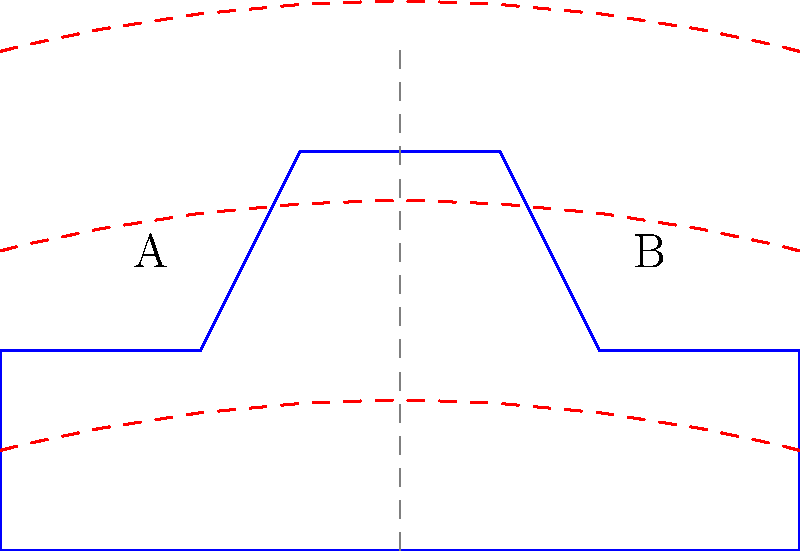In the diagram above, which area of the car design, A or B, is likely to create more drag during high-speed racing, and why? To analyze the aerodynamics of this car design, we need to consider the following steps:

1. Observe the airflow lines: The red dashed lines represent the airflow over the car.

2. Analyze the car's shape: 
   - Area A has a more abrupt transition from the hood to the windshield.
   - Area B has a smoother, more gradual slope from the roof to the rear.

3. Consider the principle of aerodynamic drag:
   - Drag increases when airflow separates from the car's surface.
   - Smooth, gradual curves allow air to flow more easily over the surface.

4. Compare the two areas:
   - Area A: The sharp angle between the hood and windshield is likely to cause air separation, creating turbulence and increasing drag.
   - Area B: The smoother curve allows air to flow more seamlessly over the surface, reducing drag.

5. Conclusion: Area A will likely create more drag during high-speed racing due to its sharper angle and potential for air separation.

This design principle is why modern race cars often have smoother, more streamlined shapes to minimize drag and improve performance at high speeds.
Answer: Area A 